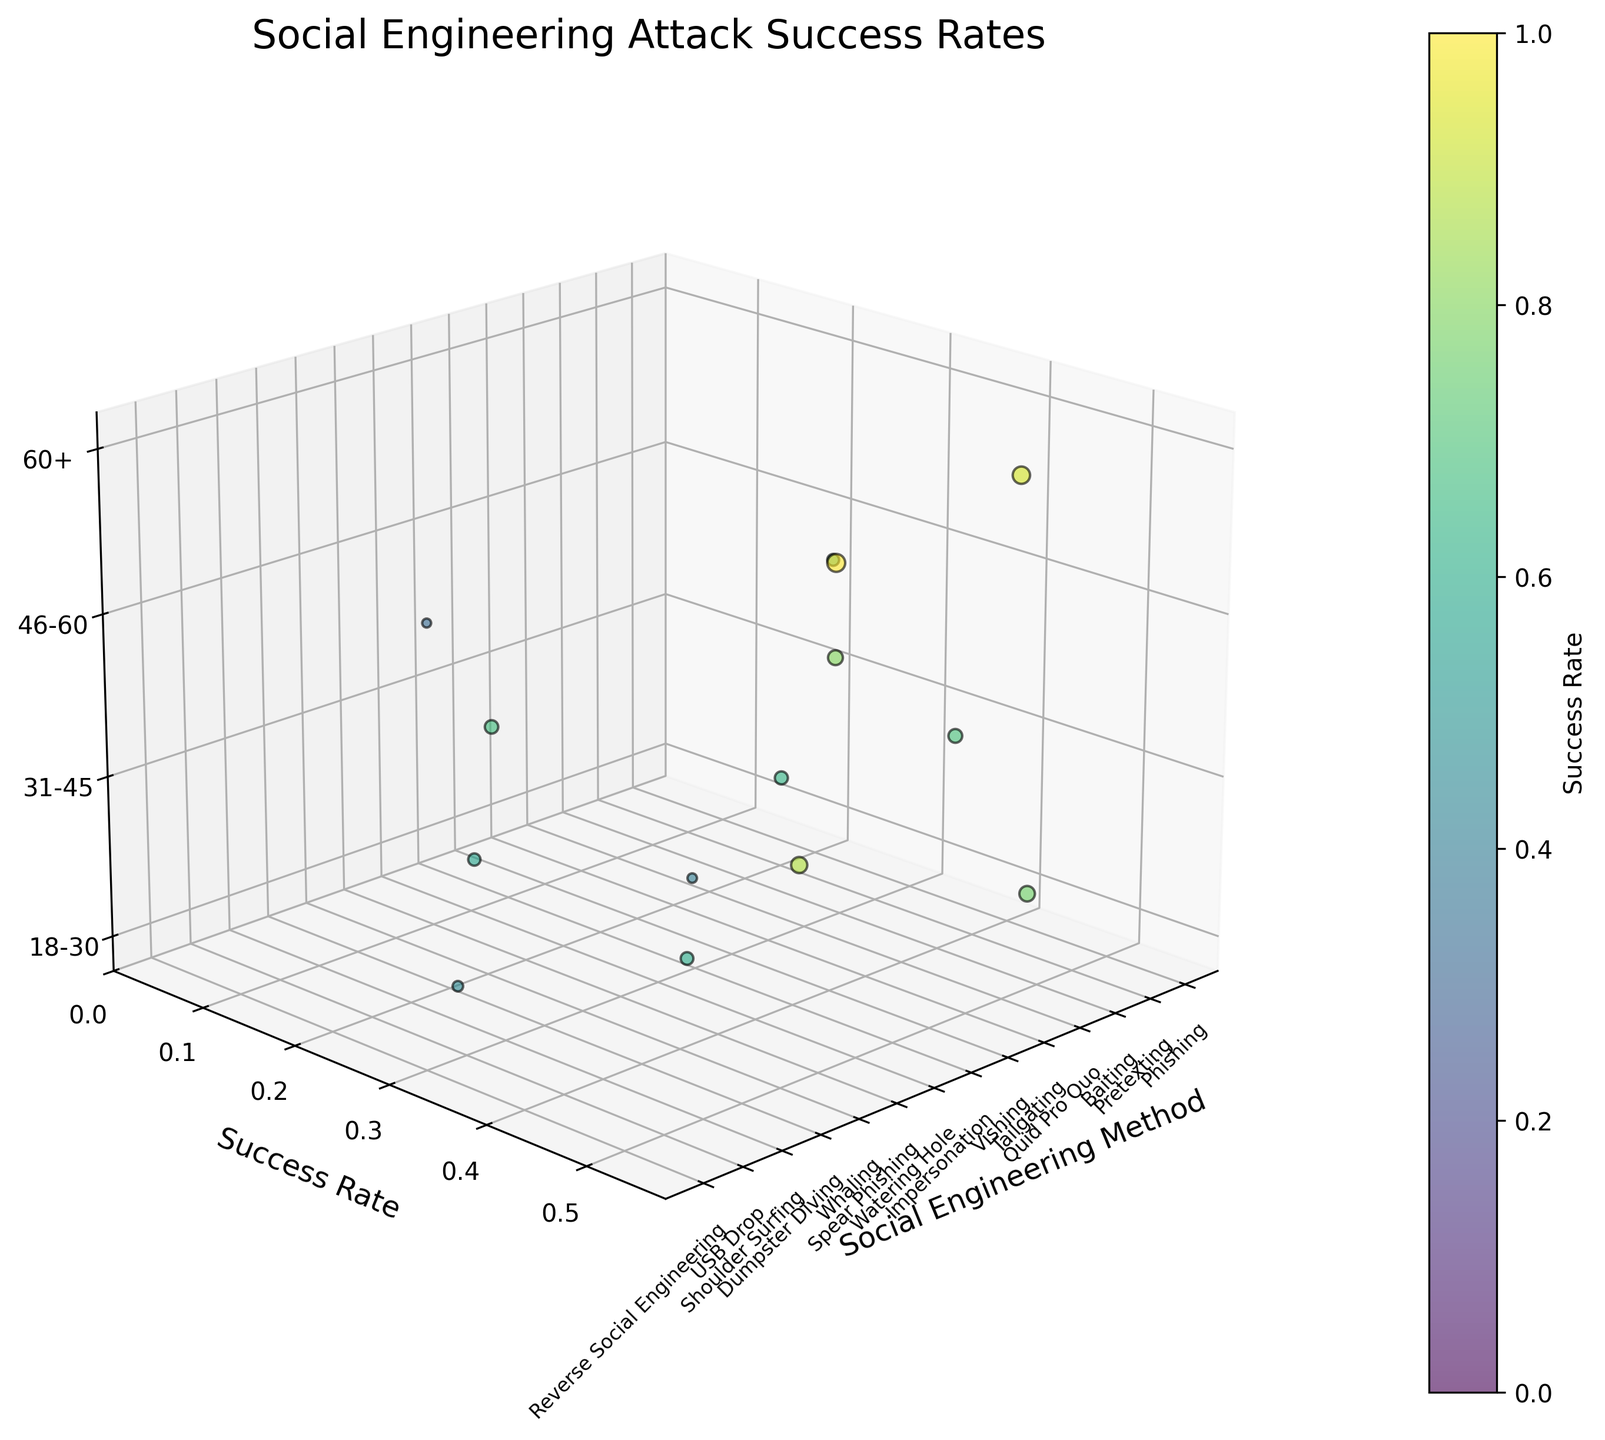Which social engineering method has the highest success rate? Identify the data points associated with success rates, check all the values and find the highest one. Whaling has a success rate of 0.55.
Answer: Whaling How does the success rate of Phishing compare to that of Pretexting? Locate the data points for Phishing and Pretexting. Phishing has a success rate of 0.42, while Pretexting has a success rate of 0.38.
Answer: Phishing has a higher success rate than Pretexting What is the average success rate across all methods? Sum all success rates and divide by the number of methods. Calculate: (0.42 + 0.38 + 0.29 + 0.51 + 0.22 + 0.35 + 0.44 + 0.33 + 0.48 + 0.55 + 0.18 + 0.25 + 0.31 + 0.37) / 14 = 0.375
Answer: 0.375 Which age group has the highest number of victims? Check the z-axis labels and find the age group with the highest bubble sizes, indicating the largest victims count. The 60+ age group has the largest bubble sizes for Quid Pro Quo and Whaling.
Answer: 60+ What is the success rate of attacks on the 46-60 age group? Locate data points on the z-axis with the label 46-60 and check the associated success rates. Identify all relevant points and list their success rates: 0.29 (Baiting), 0.44 (Impersonation), 0.18 (Dumpster Diving), and 0.37 (Reverse Social Engineering). Thus, the success rates are 0.29, 0.44, 0.18, and 0.37.
Answer: 0.29, 0.44, 0.18, 0.37 Which methods are used against the 18-30 age group with their corresponding success rates and number of victims? Identify data points where the z-axis is labeled 18-30 and check the x-axis for the corresponding methods, along with their success rates and bubble sizes (victims count): Phishing (0.42, 1200), Tailgating (0.22, 450), Watering Hole (0.33, 800), Shoulder Surfing (0.25, 550).
Answer: Phishing (0.42, 1200), Tailgating (0.22, 450), Watering Hole (0.33, 800), Shoulder Surfing (0.25, 550) How does the success rate correlate with the number of victims for Whaling and Spear Phishing? Check the values for success rates and victims count for Whaling and Spear Phishing: Whaling (0.55, 1600) and Spear Phishing (0.48, 1300). Both have relatively high success rates and large victim counts, indicating a positive correlation.
Answer: Positive correlation Compare the victims count for methods targeting the 31-45 age group. Which one has the most victims? Locate data points where the z-axis is labeled 31-45, compare their bubble sizes (victims count): Pretexting (950), Vishing (850), Spear Phishing (1300), USB Drop (750). Spear Phishing has the highest count.
Answer: Spear Phishing 